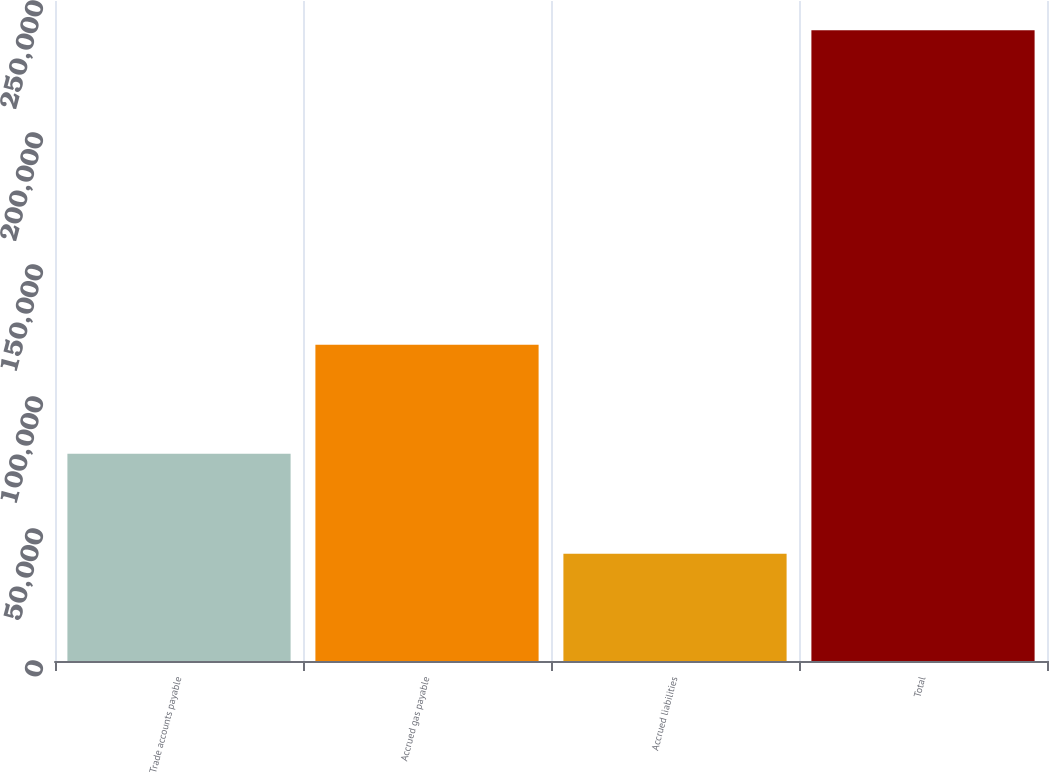Convert chart. <chart><loc_0><loc_0><loc_500><loc_500><bar_chart><fcel>Trade accounts payable<fcel>Accrued gas payable<fcel>Accrued liabilities<fcel>Total<nl><fcel>78534<fcel>119825<fcel>40583<fcel>238942<nl></chart> 